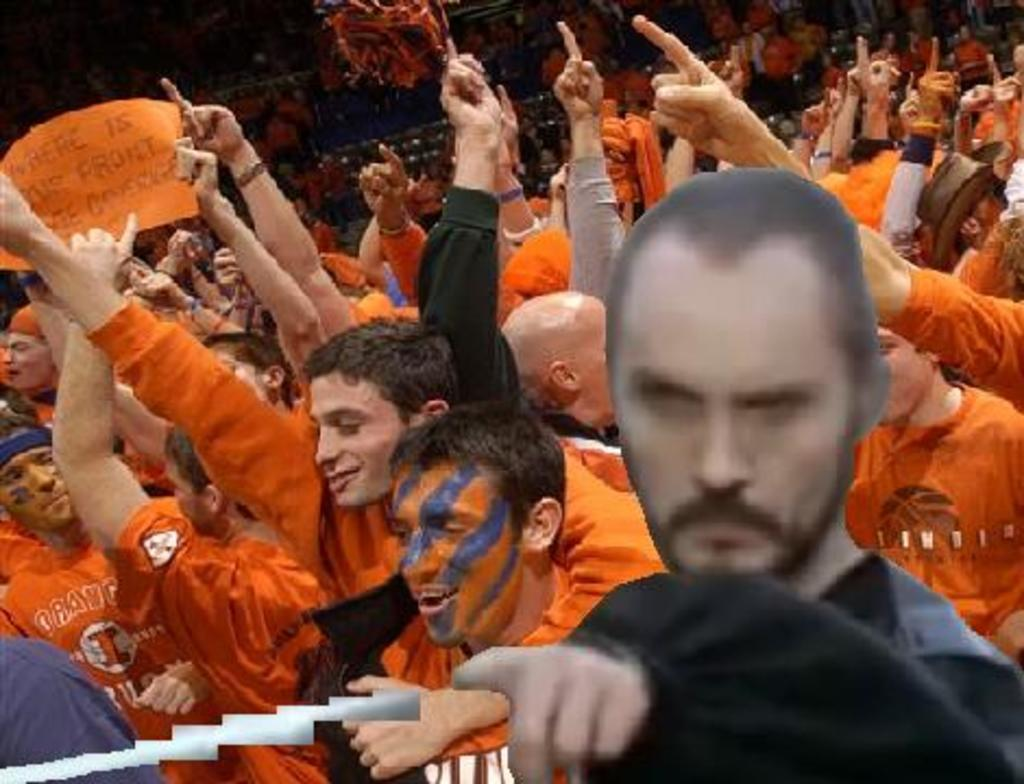What is happening with the group of people in the image? The people in the image are raising their hands. What can be observed about the clothing of the people in the image? The people are wearing clothes. Can you describe the position of the person on the left side of the image? The person on the left side is holding a paper with his hands. What type of beef can be seen in the image? There is no beef present in the image. Can you describe the cemetery in the image? There is no cemetery present in the image. 